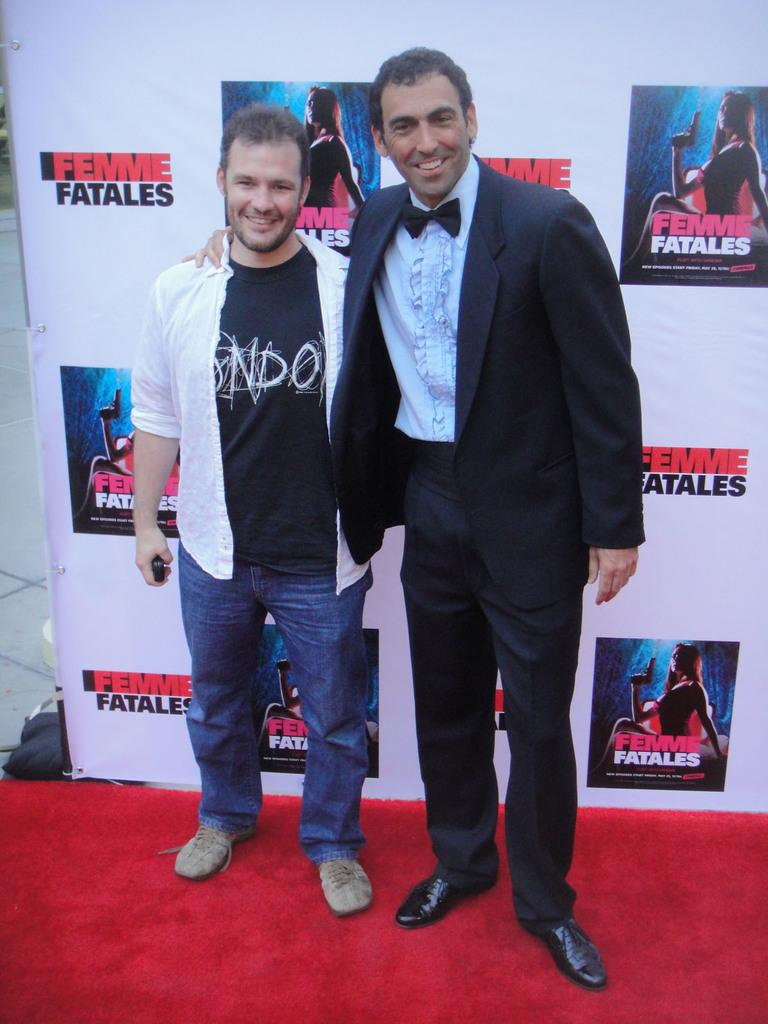How many people are in the image? There are two people in the image. What are the people doing in the image? The people are standing with smiles on their faces and posing for the camera. What can be seen in the background of the image? There is a poster visible in the background. What type of twig is being held by one of the people in the image? There is no twig present in the image; both people have their hands free and are posing for the camera. 